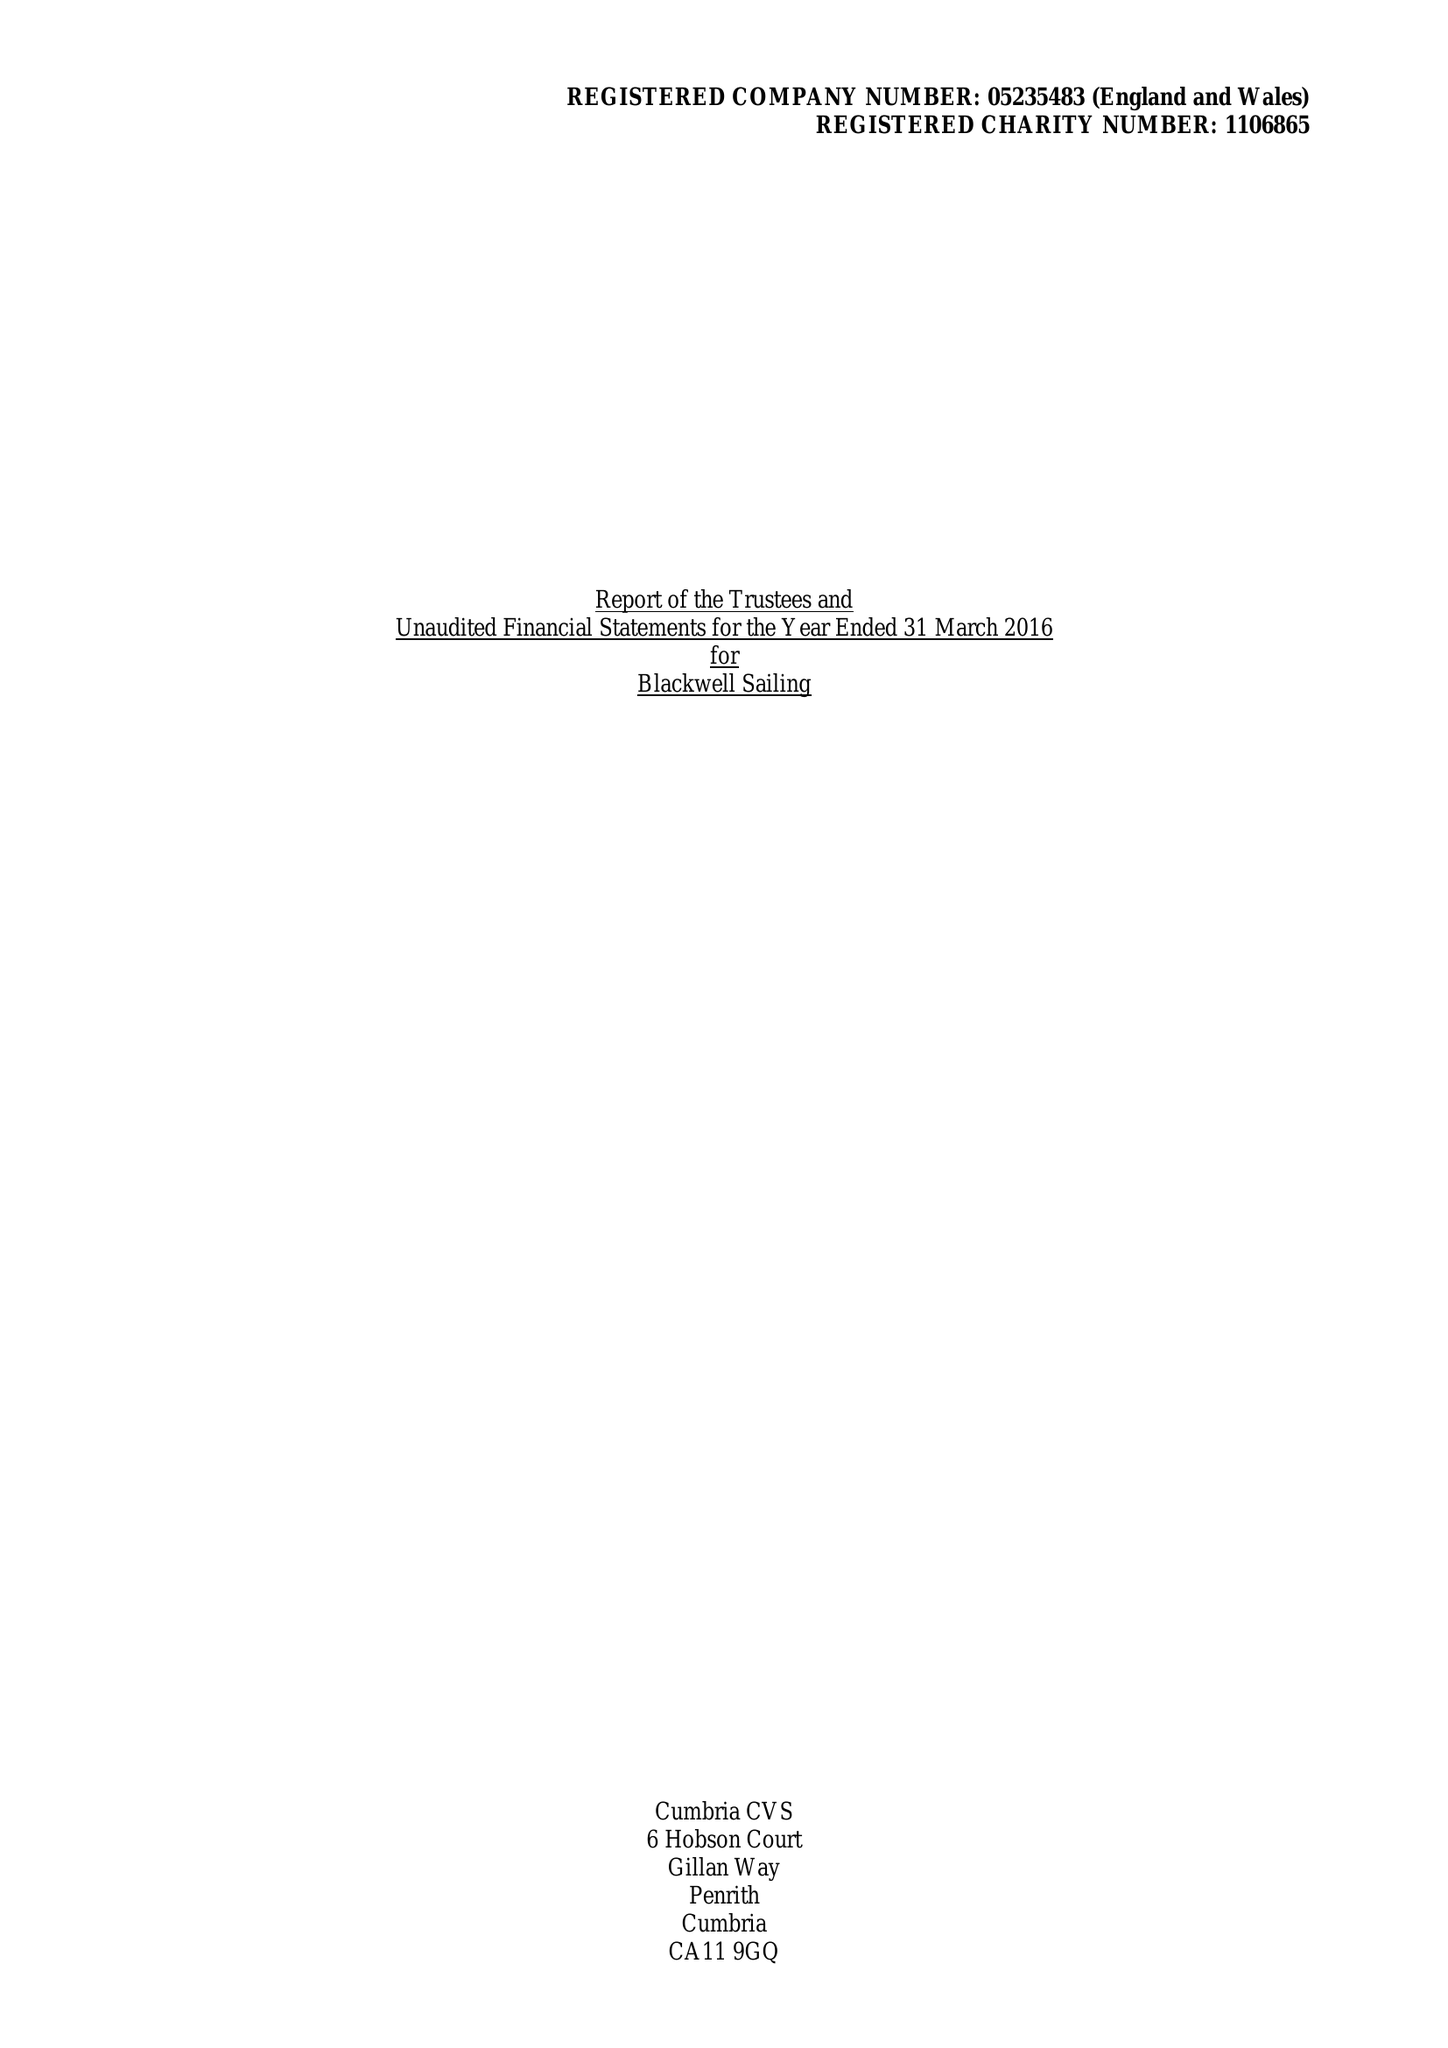What is the value for the address__postcode?
Answer the question using a single word or phrase. LA23 3HE 